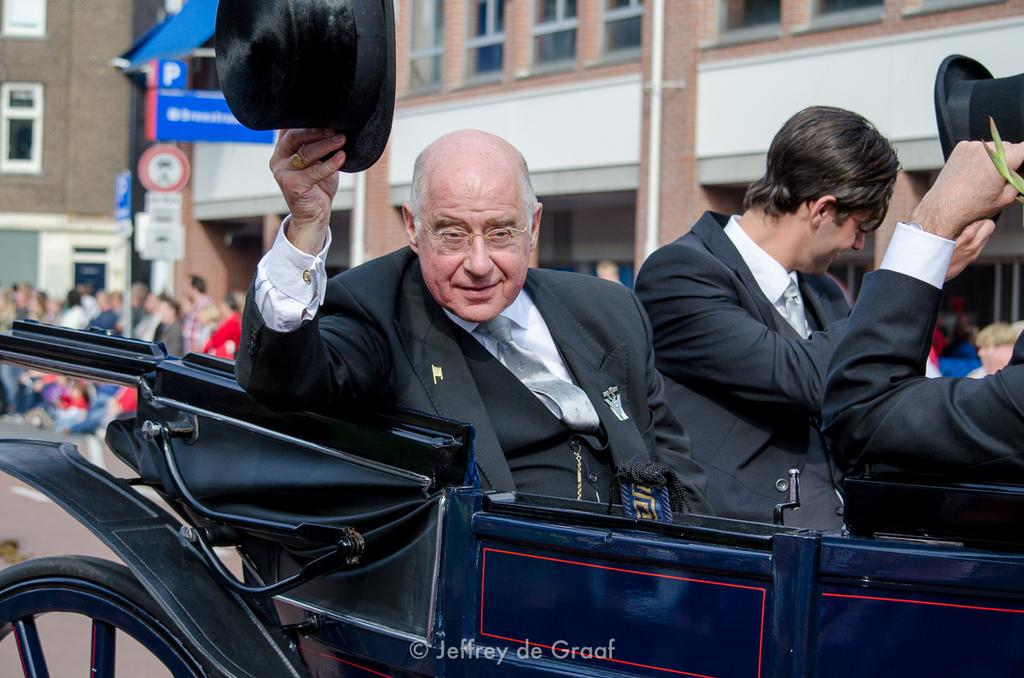How many men are in the image? There are two men in the image. What are the men doing in the image? The men are sitting in a chariot. What are the men wearing on their heads? The men are wearing hats. What can be seen in the background of the image? There are people standing and buildings visible in the background of the image. What type of space suit is the man wearing in the image? There is no space suit present in the image; the men are wearing hats. Can you see any children playing in the image? There is no mention of children or playing in the image; it features two men sitting in a chariot. 